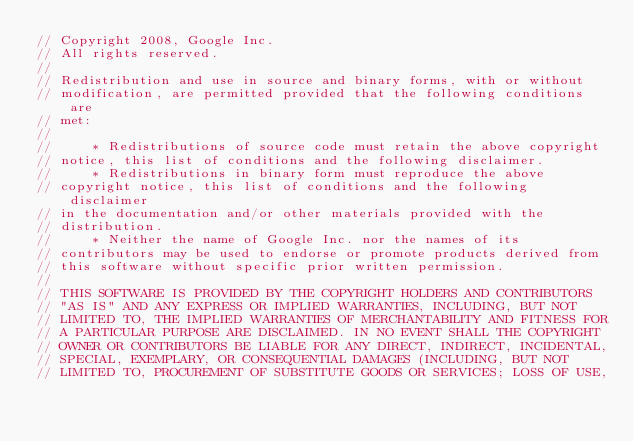<code> <loc_0><loc_0><loc_500><loc_500><_C++_>// Copyright 2008, Google Inc.
// All rights reserved.
//
// Redistribution and use in source and binary forms, with or without
// modification, are permitted provided that the following conditions are
// met:
//
//     * Redistributions of source code must retain the above copyright
// notice, this list of conditions and the following disclaimer.
//     * Redistributions in binary form must reproduce the above
// copyright notice, this list of conditions and the following disclaimer
// in the documentation and/or other materials provided with the
// distribution.
//     * Neither the name of Google Inc. nor the names of its
// contributors may be used to endorse or promote products derived from
// this software without specific prior written permission.
//
// THIS SOFTWARE IS PROVIDED BY THE COPYRIGHT HOLDERS AND CONTRIBUTORS
// "AS IS" AND ANY EXPRESS OR IMPLIED WARRANTIES, INCLUDING, BUT NOT
// LIMITED TO, THE IMPLIED WARRANTIES OF MERCHANTABILITY AND FITNESS FOR
// A PARTICULAR PURPOSE ARE DISCLAIMED. IN NO EVENT SHALL THE COPYRIGHT
// OWNER OR CONTRIBUTORS BE LIABLE FOR ANY DIRECT, INDIRECT, INCIDENTAL,
// SPECIAL, EXEMPLARY, OR CONSEQUENTIAL DAMAGES (INCLUDING, BUT NOT
// LIMITED TO, PROCUREMENT OF SUBSTITUTE GOODS OR SERVICES; LOSS OF USE,</code> 